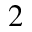<formula> <loc_0><loc_0><loc_500><loc_500>_ { 2 }</formula> 